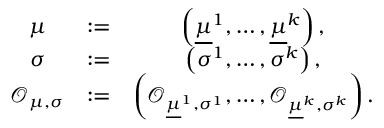<formula> <loc_0><loc_0><loc_500><loc_500>\begin{array} { c c c } { \mu } & { \colon = } & { \left ( \underline { \mu } ^ { 1 } , \dots , \underline { \mu } ^ { k } \right ) , } \\ { \sigma } & { \colon = } & { \left ( \sigma ^ { 1 } , \dots , \sigma ^ { k } \right ) , } \\ { \mathcal { O } _ { \mu , \sigma } } & { \colon = } & { \left ( \mathcal { O } _ { \underline { \mu } ^ { 1 } , \sigma ^ { 1 } } , \dots , \mathcal { O } _ { \underline { \mu } ^ { k } , \sigma ^ { k } } \right ) . } \end{array}</formula> 